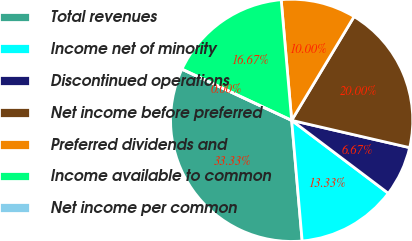Convert chart to OTSL. <chart><loc_0><loc_0><loc_500><loc_500><pie_chart><fcel>Total revenues<fcel>Income net of minority<fcel>Discontinued operations<fcel>Net income before preferred<fcel>Preferred dividends and<fcel>Income available to common<fcel>Net income per common<nl><fcel>33.33%<fcel>13.33%<fcel>6.67%<fcel>20.0%<fcel>10.0%<fcel>16.67%<fcel>0.0%<nl></chart> 